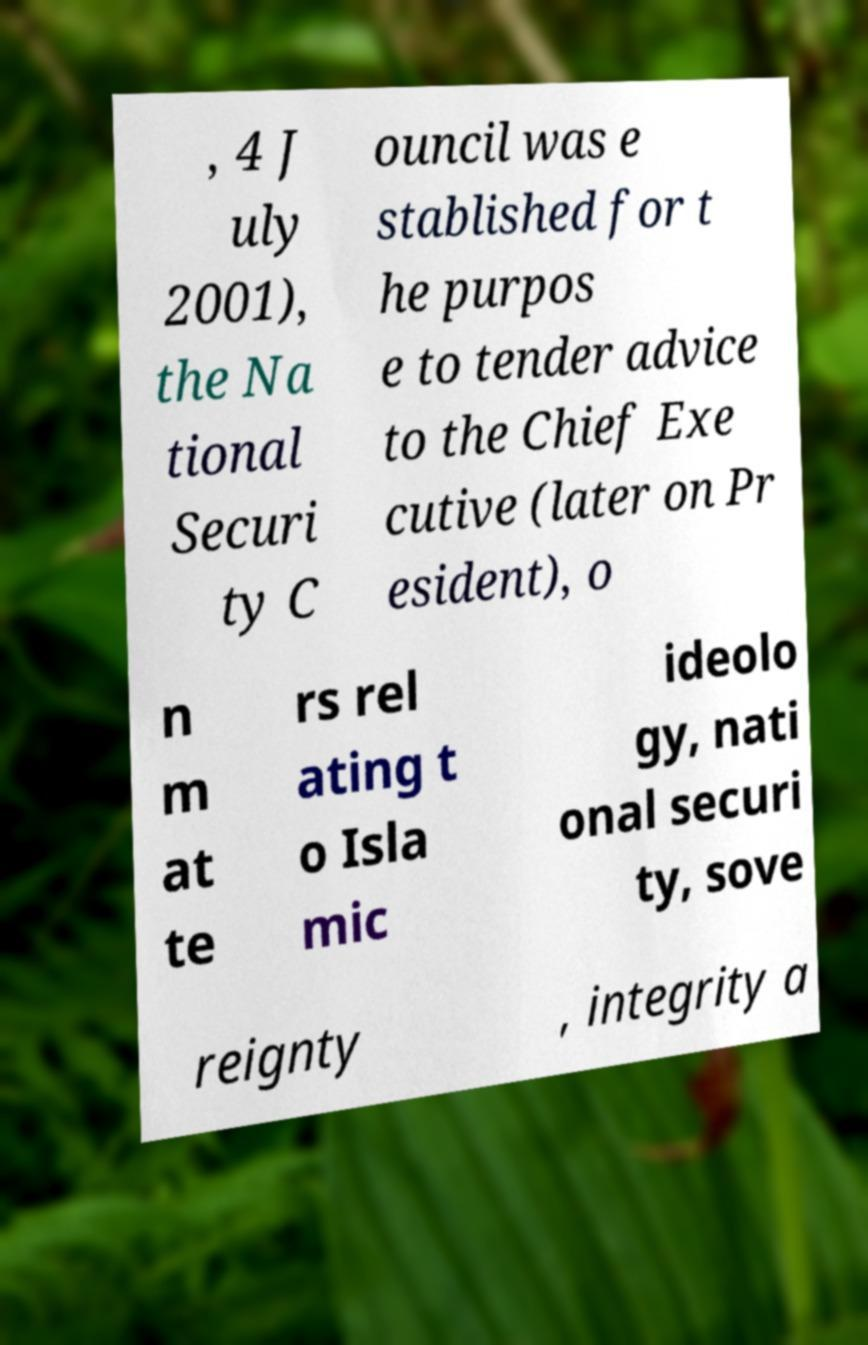Please read and relay the text visible in this image. What does it say? , 4 J uly 2001), the Na tional Securi ty C ouncil was e stablished for t he purpos e to tender advice to the Chief Exe cutive (later on Pr esident), o n m at te rs rel ating t o Isla mic ideolo gy, nati onal securi ty, sove reignty , integrity a 